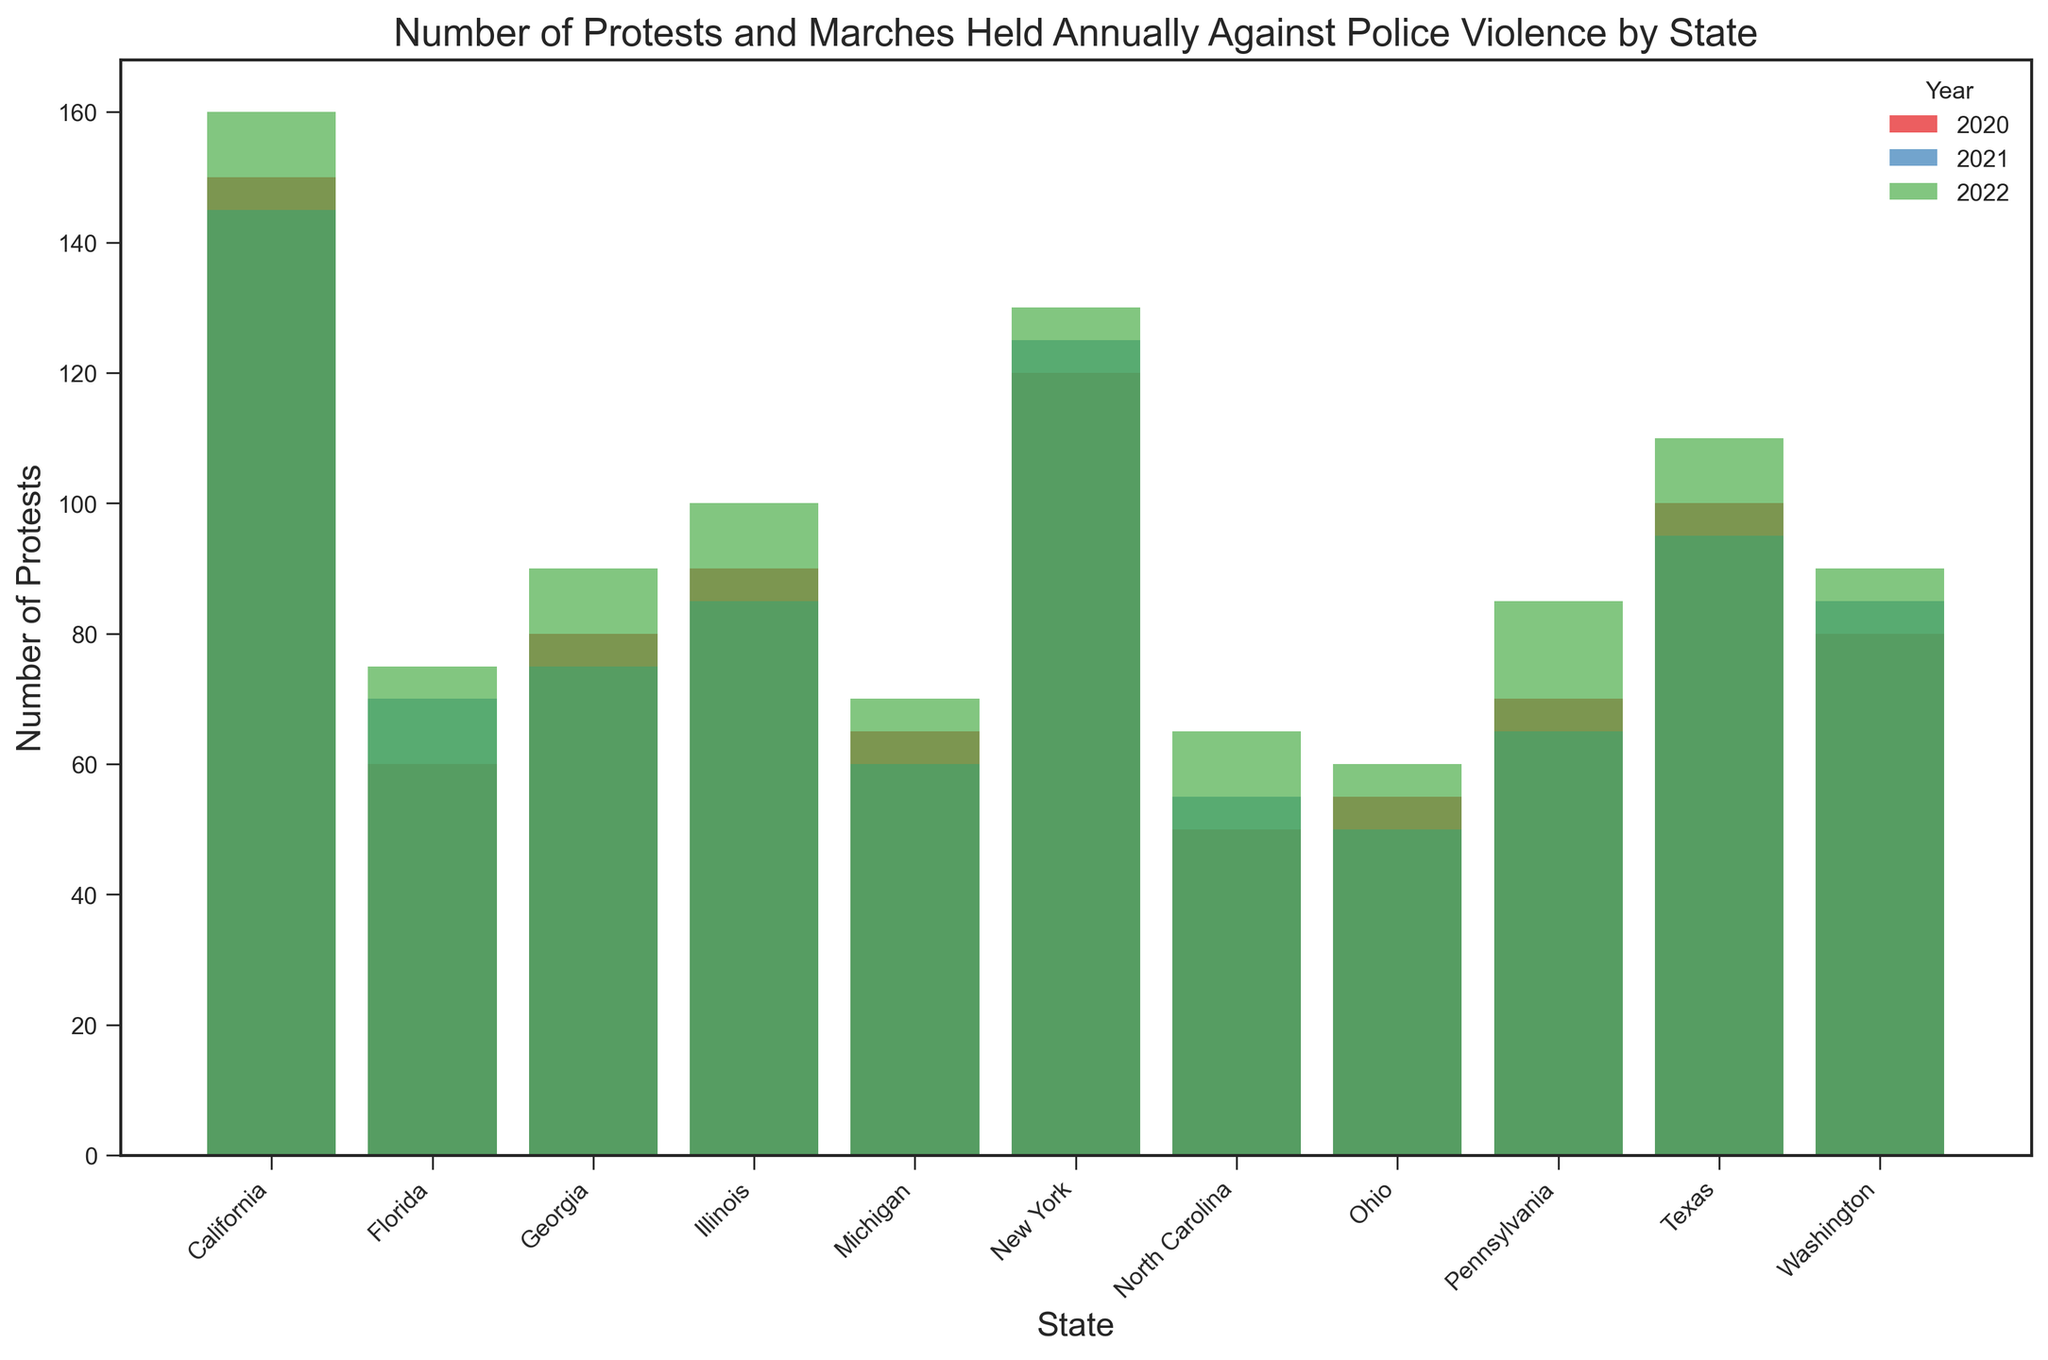Which state had the highest number of protests in 2022? By examining the heights of the bars for the year 2022, the tallest bar corresponds to California. Therefore, California had the highest number of protests in 2022.
Answer: California Which state saw the biggest increase in the number of protests from 2021 to 2022? To determine this, calculate the difference in the height of the bars from 2021 to 2022 for each state. Pennsylvania's protests increased from 65 in 2021 to 85 in 2022, a difference of 20, which is the largest increase among all states.
Answer: Pennsylvania Compare the number of protests in Texas and New York in 2021; which state had more? By comparing the height of the bars for Texas and New York in the year 2021, New York's bar is taller. Therefore, New York had more protests than Texas in 2021.
Answer: New York What is the total number of protests held in Florida over the three years? Sum the heights of the bars for Florida across all three years: 60 (2020) + 70 (2021) + 75 (2022). The total number is 205.
Answer: 205 Which state had a consistent decrease in the number of protests each year from 2020 to 2022? Examine the trend of the bar heights for each state over the years. For Ohio, the numbers continuously decreased from 55 (2020) to 50 (2021), but increased to 60 (2022). For Georgia, the pattern is not consistent either. Therefore, no state had a consistent decrease each year.
Answer: None How does the number of protests in Washington in 2022 compare with those in Georgia in 2022? Compare the height of the bars for Washington and Georgia in 2022. The bar for Washington is taller than that of Georgia.
Answer: Washington had more protests than Georgia in 2022 Which year had the lowest number of protests in Michigan? By observing the bar heights for Michigan across all years, the bar is the shortest in 2021, indicating the lowest number of protests.
Answer: 2021 What is the state with the largest decrease in protests from 2020 to 2021? By calculating the difference in bar heights for each state between 2020 and 2021, Ohio shows the largest decrease going from 55 to 50, a difference of 5.
Answer: Ohio Which three states had the highest total number of protests over the three years combined? Sum the heights of the bars for each state over the three years. California: 150+145+160=455, New York: 120+125+130=375, Texas: 100+95+110=305; California, New York, and Texas had the highest totals.
Answer: California, New York, Texas 